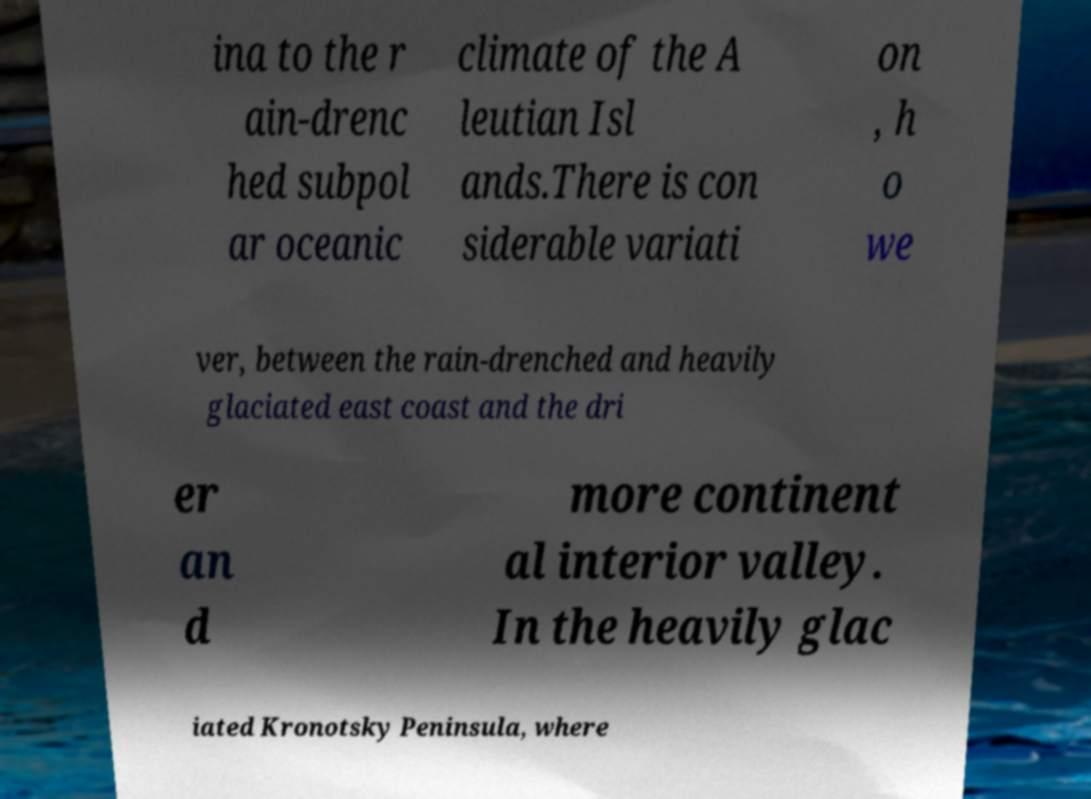There's text embedded in this image that I need extracted. Can you transcribe it verbatim? ina to the r ain-drenc hed subpol ar oceanic climate of the A leutian Isl ands.There is con siderable variati on , h o we ver, between the rain-drenched and heavily glaciated east coast and the dri er an d more continent al interior valley. In the heavily glac iated Kronotsky Peninsula, where 